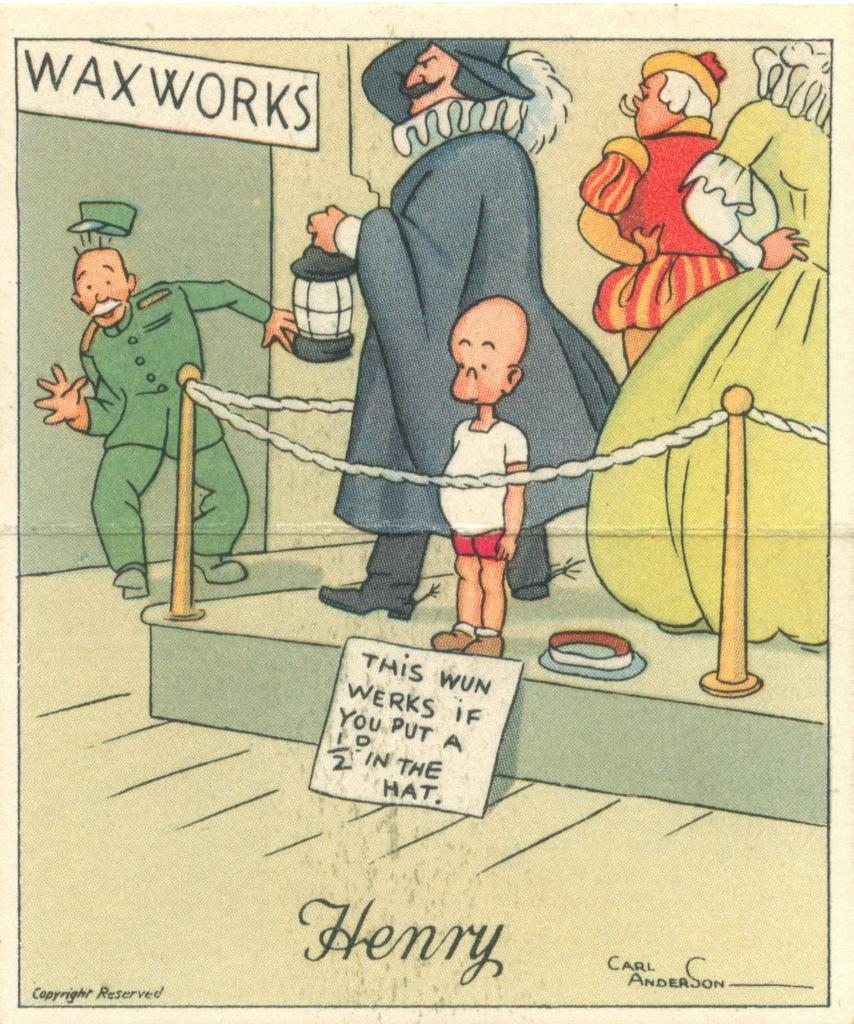Describe this image in one or two sentences. This image consists of a poster. On this poster, I can see few cartoon images and text. 